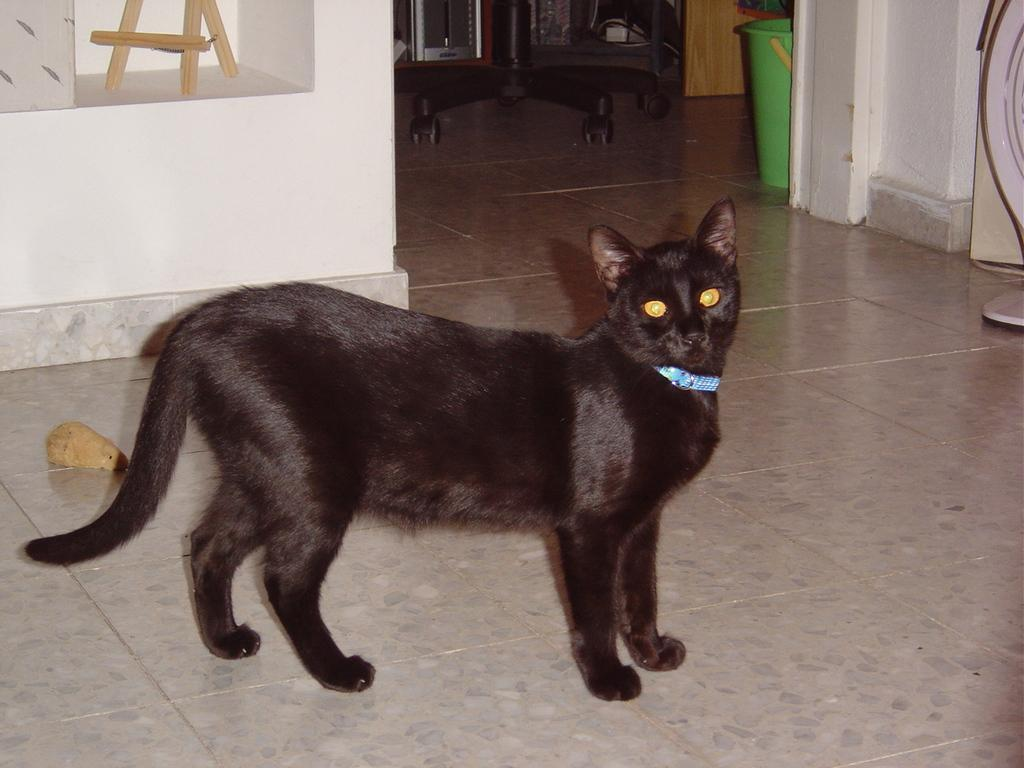What type of animal is on the floor in the image? There is a black color cat on the floor. What can be seen in the background of the image? There is a white wall and a green color object in the background. What part of the furniture is visible in the image? Table wheels are visible in the image. What type of drink is being served in the image? There is no drink present in the image. How many tomatoes are on the table in the image? There are no tomatoes present in the image. 